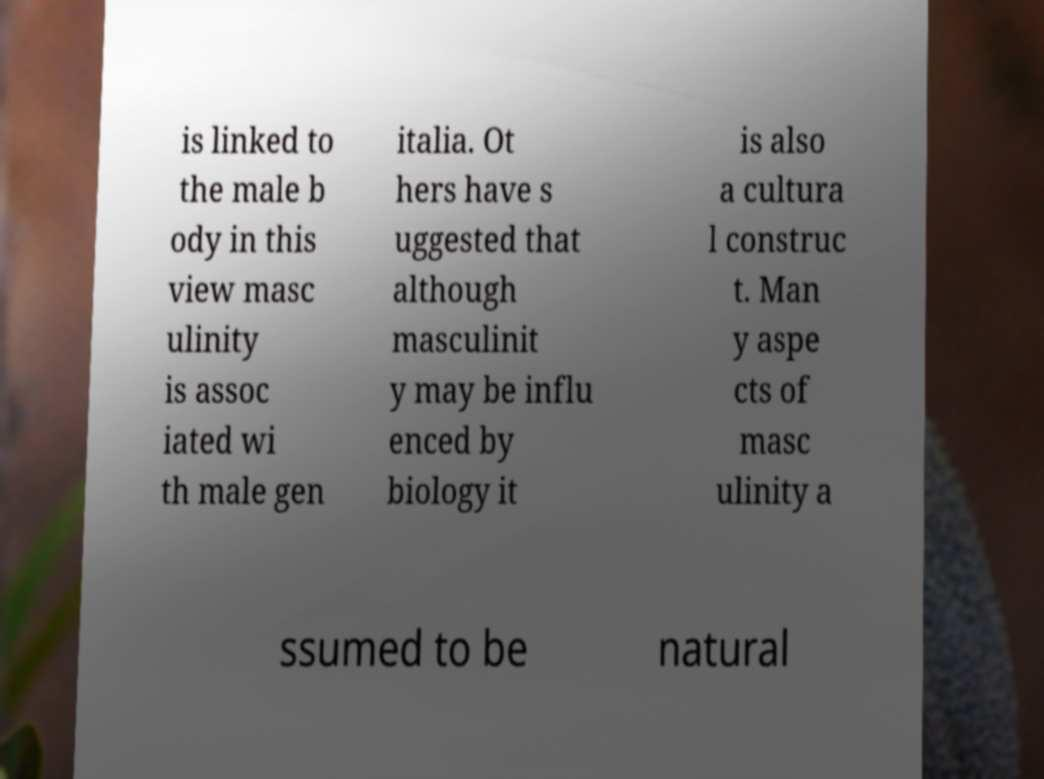Please read and relay the text visible in this image. What does it say? is linked to the male b ody in this view masc ulinity is assoc iated wi th male gen italia. Ot hers have s uggested that although masculinit y may be influ enced by biology it is also a cultura l construc t. Man y aspe cts of masc ulinity a ssumed to be natural 